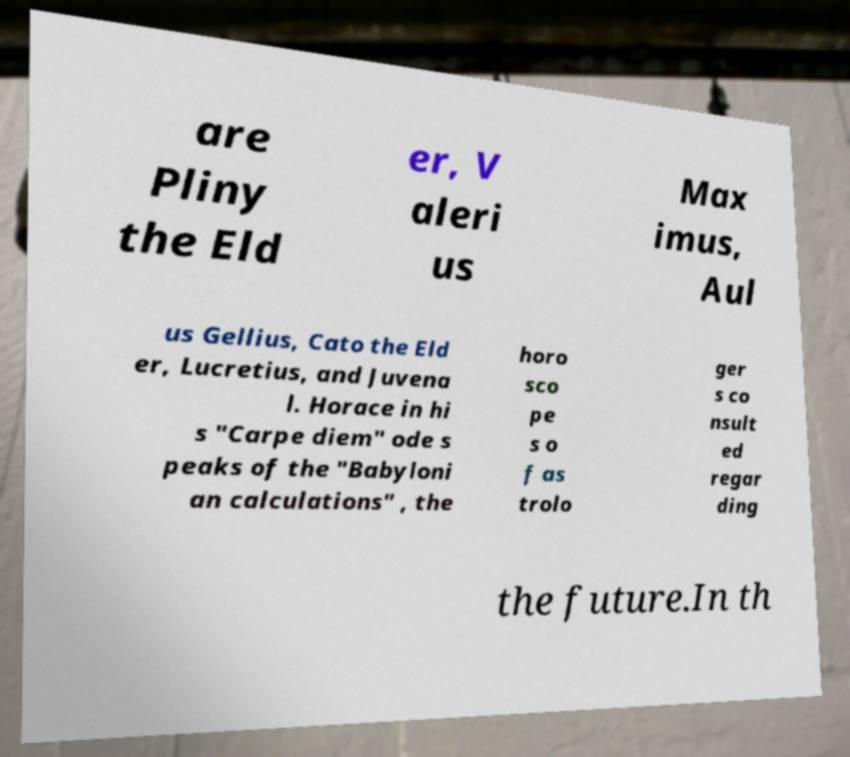I need the written content from this picture converted into text. Can you do that? are Pliny the Eld er, V aleri us Max imus, Aul us Gellius, Cato the Eld er, Lucretius, and Juvena l. Horace in hi s "Carpe diem" ode s peaks of the "Babyloni an calculations" , the horo sco pe s o f as trolo ger s co nsult ed regar ding the future.In th 